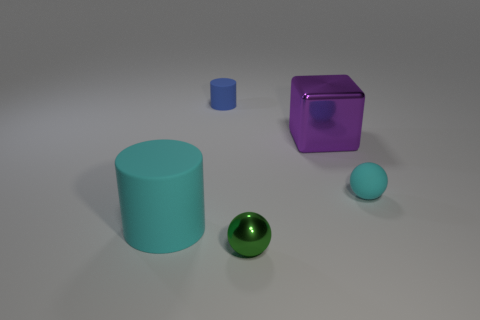What is the size of the object to the right of the metallic object on the right side of the green metal sphere?
Keep it short and to the point. Small. How many metallic spheres have the same color as the small rubber ball?
Keep it short and to the point. 0. What number of big blue matte spheres are there?
Give a very brief answer. 0. How many big cyan cylinders have the same material as the cyan sphere?
Offer a very short reply. 1. There is another thing that is the same shape as the small green thing; what is its size?
Offer a very short reply. Small. What is the material of the green ball?
Make the answer very short. Metal. There is a cyan object that is right of the matte cylinder in front of the matte object that is to the right of the tiny metallic sphere; what is its material?
Ensure brevity in your answer.  Rubber. Is there anything else that has the same shape as the blue object?
Your answer should be very brief. Yes. The other object that is the same shape as the green metal object is what color?
Make the answer very short. Cyan. There is a ball behind the cyan matte cylinder; does it have the same color as the big object to the right of the shiny ball?
Offer a very short reply. No. 